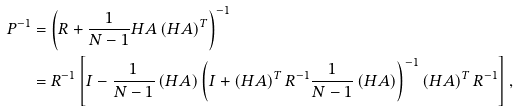<formula> <loc_0><loc_0><loc_500><loc_500>P ^ { - 1 } & = \left ( R + \frac { 1 } { N - 1 } H A \left ( H A \right ) ^ { T } \right ) ^ { - 1 } \\ & = R ^ { - 1 } \left [ I - \frac { 1 } { N - 1 } \left ( H A \right ) \left ( I + \left ( H A \right ) ^ { T } R ^ { - 1 } \frac { 1 } { N - 1 } \left ( H A \right ) \right ) ^ { - 1 } \left ( H A \right ) ^ { T } R ^ { - 1 } \right ] ,</formula> 